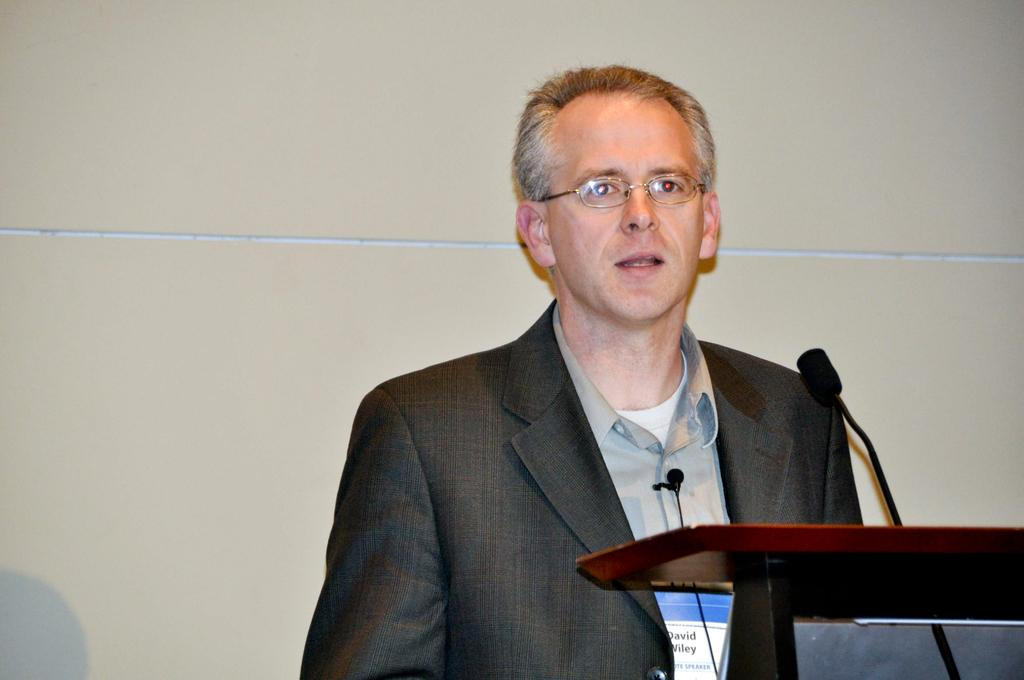What is the man in the image doing? The man is standing and talking in the image. What object is present on the podium in the foreground? There is a microphone on a podium in the foreground. What can be seen behind the man in the image? There is a wall visible in the background. What type of trail can be seen behind the man in the image? There is no trail visible in the image; it features a man standing and talking with a microphone on a podium and a wall in the background. 